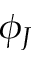<formula> <loc_0><loc_0><loc_500><loc_500>\phi _ { J }</formula> 